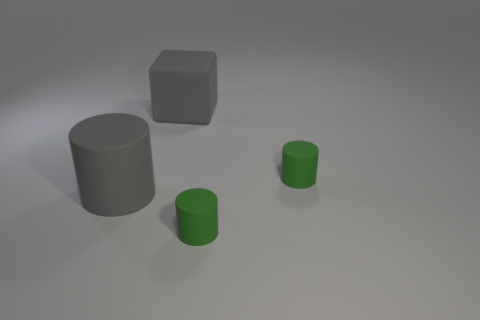What number of green rubber things are the same size as the gray cube?
Your response must be concise. 0. Does the big gray object on the left side of the gray block have the same material as the big cube?
Make the answer very short. Yes. Are there any cylinders?
Offer a terse response. Yes. There is a cube that is made of the same material as the big gray cylinder; what is its size?
Give a very brief answer. Large. Is there a small shiny block that has the same color as the rubber block?
Keep it short and to the point. No. There is a cylinder to the left of the gray rubber cube; is it the same color as the large rubber thing behind the big gray cylinder?
Your response must be concise. Yes. There is a cylinder that is the same color as the rubber cube; what is its size?
Provide a succinct answer. Large. Are there any big yellow cylinders made of the same material as the gray block?
Your answer should be very brief. No. What color is the large cylinder?
Your answer should be compact. Gray. There is a gray thing that is in front of the green matte object behind the big cylinder that is in front of the big block; what is its size?
Your answer should be very brief. Large. 